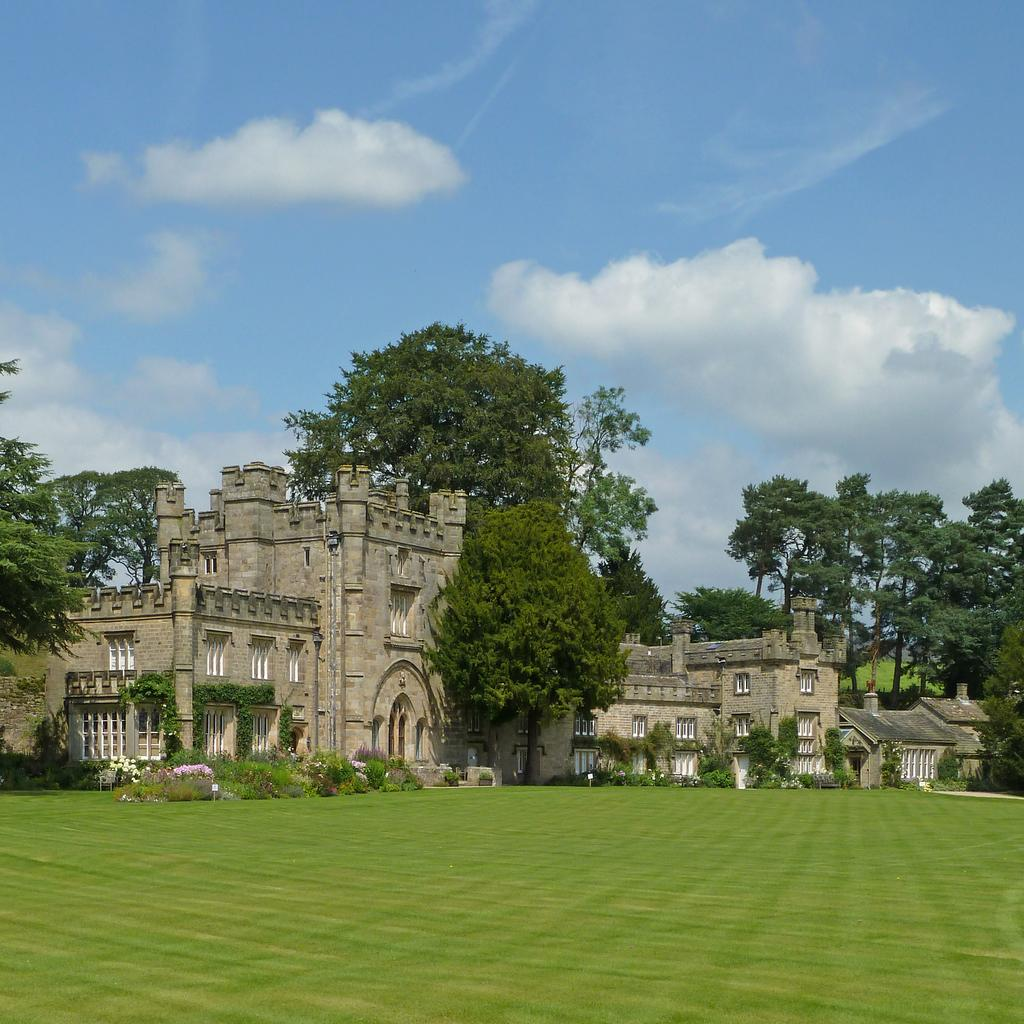What type of outdoor area is depicted in the image? There is a garden in the image. What can be found within the garden? The garden contains plants. What can be seen in the distance behind the garden? There is a building, houses, trees, and the sky visible in the background of the image. What type of holiday is being celebrated in the garden? There is no indication of a holiday being celebrated in the image; it simply depicts a garden with plants. Can you spot any squirrels in the garden or background? There are no squirrels visible in the image. 